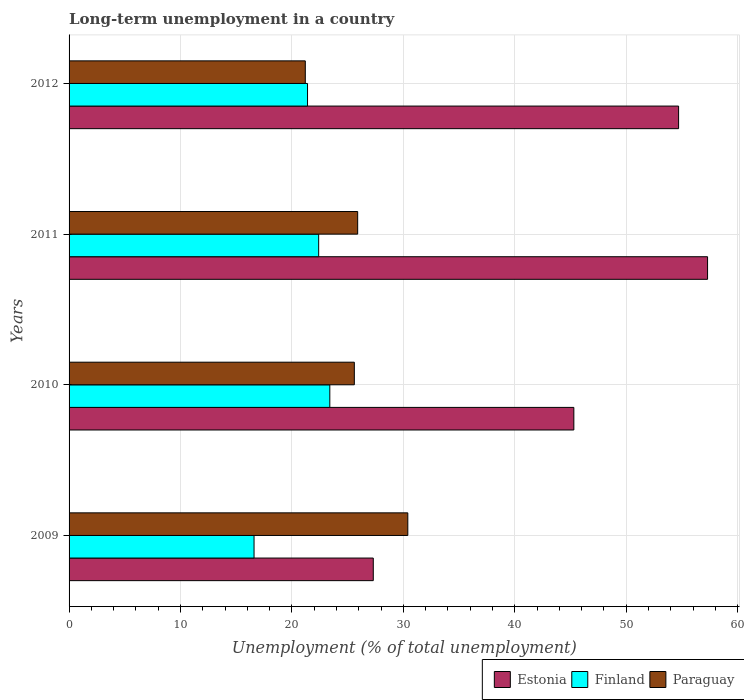How many different coloured bars are there?
Offer a very short reply. 3. How many groups of bars are there?
Your answer should be compact. 4. Are the number of bars on each tick of the Y-axis equal?
Keep it short and to the point. Yes. How many bars are there on the 4th tick from the top?
Provide a short and direct response. 3. What is the label of the 2nd group of bars from the top?
Provide a short and direct response. 2011. In how many cases, is the number of bars for a given year not equal to the number of legend labels?
Your response must be concise. 0. What is the percentage of long-term unemployed population in Paraguay in 2012?
Give a very brief answer. 21.2. Across all years, what is the maximum percentage of long-term unemployed population in Paraguay?
Ensure brevity in your answer.  30.4. Across all years, what is the minimum percentage of long-term unemployed population in Paraguay?
Provide a succinct answer. 21.2. What is the total percentage of long-term unemployed population in Finland in the graph?
Your answer should be compact. 83.8. What is the difference between the percentage of long-term unemployed population in Paraguay in 2009 and that in 2011?
Your answer should be very brief. 4.5. What is the difference between the percentage of long-term unemployed population in Estonia in 2010 and the percentage of long-term unemployed population in Paraguay in 2009?
Keep it short and to the point. 14.9. What is the average percentage of long-term unemployed population in Estonia per year?
Give a very brief answer. 46.15. In the year 2012, what is the difference between the percentage of long-term unemployed population in Finland and percentage of long-term unemployed population in Estonia?
Provide a succinct answer. -33.3. In how many years, is the percentage of long-term unemployed population in Paraguay greater than 38 %?
Give a very brief answer. 0. What is the ratio of the percentage of long-term unemployed population in Finland in 2011 to that in 2012?
Your response must be concise. 1.05. What is the difference between the highest and the lowest percentage of long-term unemployed population in Paraguay?
Your response must be concise. 9.2. What does the 1st bar from the bottom in 2012 represents?
Offer a very short reply. Estonia. Is it the case that in every year, the sum of the percentage of long-term unemployed population in Paraguay and percentage of long-term unemployed population in Estonia is greater than the percentage of long-term unemployed population in Finland?
Keep it short and to the point. Yes. Are all the bars in the graph horizontal?
Offer a very short reply. Yes. How many years are there in the graph?
Your answer should be compact. 4. What is the difference between two consecutive major ticks on the X-axis?
Offer a very short reply. 10. Are the values on the major ticks of X-axis written in scientific E-notation?
Offer a terse response. No. Does the graph contain any zero values?
Make the answer very short. No. How many legend labels are there?
Give a very brief answer. 3. How are the legend labels stacked?
Your answer should be compact. Horizontal. What is the title of the graph?
Offer a terse response. Long-term unemployment in a country. What is the label or title of the X-axis?
Provide a succinct answer. Unemployment (% of total unemployment). What is the label or title of the Y-axis?
Ensure brevity in your answer.  Years. What is the Unemployment (% of total unemployment) in Estonia in 2009?
Provide a short and direct response. 27.3. What is the Unemployment (% of total unemployment) of Finland in 2009?
Offer a very short reply. 16.6. What is the Unemployment (% of total unemployment) in Paraguay in 2009?
Your answer should be compact. 30.4. What is the Unemployment (% of total unemployment) of Estonia in 2010?
Your response must be concise. 45.3. What is the Unemployment (% of total unemployment) in Finland in 2010?
Make the answer very short. 23.4. What is the Unemployment (% of total unemployment) of Paraguay in 2010?
Your response must be concise. 25.6. What is the Unemployment (% of total unemployment) of Estonia in 2011?
Provide a short and direct response. 57.3. What is the Unemployment (% of total unemployment) in Finland in 2011?
Provide a short and direct response. 22.4. What is the Unemployment (% of total unemployment) in Paraguay in 2011?
Ensure brevity in your answer.  25.9. What is the Unemployment (% of total unemployment) in Estonia in 2012?
Offer a terse response. 54.7. What is the Unemployment (% of total unemployment) of Finland in 2012?
Give a very brief answer. 21.4. What is the Unemployment (% of total unemployment) of Paraguay in 2012?
Your answer should be compact. 21.2. Across all years, what is the maximum Unemployment (% of total unemployment) of Estonia?
Give a very brief answer. 57.3. Across all years, what is the maximum Unemployment (% of total unemployment) in Finland?
Give a very brief answer. 23.4. Across all years, what is the maximum Unemployment (% of total unemployment) in Paraguay?
Ensure brevity in your answer.  30.4. Across all years, what is the minimum Unemployment (% of total unemployment) of Estonia?
Ensure brevity in your answer.  27.3. Across all years, what is the minimum Unemployment (% of total unemployment) of Finland?
Your answer should be very brief. 16.6. Across all years, what is the minimum Unemployment (% of total unemployment) in Paraguay?
Make the answer very short. 21.2. What is the total Unemployment (% of total unemployment) of Estonia in the graph?
Provide a short and direct response. 184.6. What is the total Unemployment (% of total unemployment) in Finland in the graph?
Provide a succinct answer. 83.8. What is the total Unemployment (% of total unemployment) of Paraguay in the graph?
Your answer should be very brief. 103.1. What is the difference between the Unemployment (% of total unemployment) in Estonia in 2009 and that in 2010?
Provide a short and direct response. -18. What is the difference between the Unemployment (% of total unemployment) of Estonia in 2009 and that in 2011?
Keep it short and to the point. -30. What is the difference between the Unemployment (% of total unemployment) in Paraguay in 2009 and that in 2011?
Provide a succinct answer. 4.5. What is the difference between the Unemployment (% of total unemployment) in Estonia in 2009 and that in 2012?
Keep it short and to the point. -27.4. What is the difference between the Unemployment (% of total unemployment) of Finland in 2009 and that in 2012?
Give a very brief answer. -4.8. What is the difference between the Unemployment (% of total unemployment) of Paraguay in 2009 and that in 2012?
Give a very brief answer. 9.2. What is the difference between the Unemployment (% of total unemployment) of Estonia in 2010 and that in 2011?
Make the answer very short. -12. What is the difference between the Unemployment (% of total unemployment) in Finland in 2010 and that in 2011?
Your response must be concise. 1. What is the difference between the Unemployment (% of total unemployment) of Finland in 2010 and that in 2012?
Offer a very short reply. 2. What is the difference between the Unemployment (% of total unemployment) of Paraguay in 2010 and that in 2012?
Give a very brief answer. 4.4. What is the difference between the Unemployment (% of total unemployment) in Estonia in 2011 and that in 2012?
Your response must be concise. 2.6. What is the difference between the Unemployment (% of total unemployment) in Finland in 2011 and that in 2012?
Provide a short and direct response. 1. What is the difference between the Unemployment (% of total unemployment) of Paraguay in 2011 and that in 2012?
Your answer should be very brief. 4.7. What is the difference between the Unemployment (% of total unemployment) of Estonia in 2009 and the Unemployment (% of total unemployment) of Paraguay in 2010?
Provide a short and direct response. 1.7. What is the difference between the Unemployment (% of total unemployment) in Finland in 2009 and the Unemployment (% of total unemployment) in Paraguay in 2010?
Ensure brevity in your answer.  -9. What is the difference between the Unemployment (% of total unemployment) of Estonia in 2009 and the Unemployment (% of total unemployment) of Finland in 2011?
Give a very brief answer. 4.9. What is the difference between the Unemployment (% of total unemployment) in Estonia in 2009 and the Unemployment (% of total unemployment) in Paraguay in 2011?
Make the answer very short. 1.4. What is the difference between the Unemployment (% of total unemployment) of Finland in 2009 and the Unemployment (% of total unemployment) of Paraguay in 2011?
Keep it short and to the point. -9.3. What is the difference between the Unemployment (% of total unemployment) of Estonia in 2009 and the Unemployment (% of total unemployment) of Paraguay in 2012?
Offer a terse response. 6.1. What is the difference between the Unemployment (% of total unemployment) in Finland in 2009 and the Unemployment (% of total unemployment) in Paraguay in 2012?
Your answer should be very brief. -4.6. What is the difference between the Unemployment (% of total unemployment) of Estonia in 2010 and the Unemployment (% of total unemployment) of Finland in 2011?
Offer a terse response. 22.9. What is the difference between the Unemployment (% of total unemployment) in Finland in 2010 and the Unemployment (% of total unemployment) in Paraguay in 2011?
Offer a terse response. -2.5. What is the difference between the Unemployment (% of total unemployment) of Estonia in 2010 and the Unemployment (% of total unemployment) of Finland in 2012?
Keep it short and to the point. 23.9. What is the difference between the Unemployment (% of total unemployment) of Estonia in 2010 and the Unemployment (% of total unemployment) of Paraguay in 2012?
Your response must be concise. 24.1. What is the difference between the Unemployment (% of total unemployment) of Finland in 2010 and the Unemployment (% of total unemployment) of Paraguay in 2012?
Your response must be concise. 2.2. What is the difference between the Unemployment (% of total unemployment) of Estonia in 2011 and the Unemployment (% of total unemployment) of Finland in 2012?
Offer a terse response. 35.9. What is the difference between the Unemployment (% of total unemployment) in Estonia in 2011 and the Unemployment (% of total unemployment) in Paraguay in 2012?
Your response must be concise. 36.1. What is the difference between the Unemployment (% of total unemployment) of Finland in 2011 and the Unemployment (% of total unemployment) of Paraguay in 2012?
Provide a succinct answer. 1.2. What is the average Unemployment (% of total unemployment) of Estonia per year?
Provide a succinct answer. 46.15. What is the average Unemployment (% of total unemployment) of Finland per year?
Make the answer very short. 20.95. What is the average Unemployment (% of total unemployment) in Paraguay per year?
Give a very brief answer. 25.77. In the year 2009, what is the difference between the Unemployment (% of total unemployment) in Estonia and Unemployment (% of total unemployment) in Finland?
Your answer should be compact. 10.7. In the year 2009, what is the difference between the Unemployment (% of total unemployment) of Estonia and Unemployment (% of total unemployment) of Paraguay?
Provide a succinct answer. -3.1. In the year 2009, what is the difference between the Unemployment (% of total unemployment) in Finland and Unemployment (% of total unemployment) in Paraguay?
Offer a very short reply. -13.8. In the year 2010, what is the difference between the Unemployment (% of total unemployment) in Estonia and Unemployment (% of total unemployment) in Finland?
Offer a very short reply. 21.9. In the year 2010, what is the difference between the Unemployment (% of total unemployment) of Estonia and Unemployment (% of total unemployment) of Paraguay?
Keep it short and to the point. 19.7. In the year 2011, what is the difference between the Unemployment (% of total unemployment) in Estonia and Unemployment (% of total unemployment) in Finland?
Keep it short and to the point. 34.9. In the year 2011, what is the difference between the Unemployment (% of total unemployment) of Estonia and Unemployment (% of total unemployment) of Paraguay?
Keep it short and to the point. 31.4. In the year 2011, what is the difference between the Unemployment (% of total unemployment) in Finland and Unemployment (% of total unemployment) in Paraguay?
Your response must be concise. -3.5. In the year 2012, what is the difference between the Unemployment (% of total unemployment) in Estonia and Unemployment (% of total unemployment) in Finland?
Ensure brevity in your answer.  33.3. In the year 2012, what is the difference between the Unemployment (% of total unemployment) in Estonia and Unemployment (% of total unemployment) in Paraguay?
Give a very brief answer. 33.5. What is the ratio of the Unemployment (% of total unemployment) of Estonia in 2009 to that in 2010?
Provide a succinct answer. 0.6. What is the ratio of the Unemployment (% of total unemployment) in Finland in 2009 to that in 2010?
Make the answer very short. 0.71. What is the ratio of the Unemployment (% of total unemployment) of Paraguay in 2009 to that in 2010?
Your answer should be compact. 1.19. What is the ratio of the Unemployment (% of total unemployment) in Estonia in 2009 to that in 2011?
Give a very brief answer. 0.48. What is the ratio of the Unemployment (% of total unemployment) of Finland in 2009 to that in 2011?
Your answer should be very brief. 0.74. What is the ratio of the Unemployment (% of total unemployment) in Paraguay in 2009 to that in 2011?
Make the answer very short. 1.17. What is the ratio of the Unemployment (% of total unemployment) of Estonia in 2009 to that in 2012?
Provide a short and direct response. 0.5. What is the ratio of the Unemployment (% of total unemployment) in Finland in 2009 to that in 2012?
Offer a very short reply. 0.78. What is the ratio of the Unemployment (% of total unemployment) of Paraguay in 2009 to that in 2012?
Give a very brief answer. 1.43. What is the ratio of the Unemployment (% of total unemployment) in Estonia in 2010 to that in 2011?
Your answer should be very brief. 0.79. What is the ratio of the Unemployment (% of total unemployment) of Finland in 2010 to that in 2011?
Provide a succinct answer. 1.04. What is the ratio of the Unemployment (% of total unemployment) in Paraguay in 2010 to that in 2011?
Ensure brevity in your answer.  0.99. What is the ratio of the Unemployment (% of total unemployment) of Estonia in 2010 to that in 2012?
Make the answer very short. 0.83. What is the ratio of the Unemployment (% of total unemployment) of Finland in 2010 to that in 2012?
Your response must be concise. 1.09. What is the ratio of the Unemployment (% of total unemployment) in Paraguay in 2010 to that in 2012?
Keep it short and to the point. 1.21. What is the ratio of the Unemployment (% of total unemployment) of Estonia in 2011 to that in 2012?
Your response must be concise. 1.05. What is the ratio of the Unemployment (% of total unemployment) in Finland in 2011 to that in 2012?
Keep it short and to the point. 1.05. What is the ratio of the Unemployment (% of total unemployment) in Paraguay in 2011 to that in 2012?
Give a very brief answer. 1.22. What is the difference between the highest and the lowest Unemployment (% of total unemployment) of Finland?
Offer a terse response. 6.8. What is the difference between the highest and the lowest Unemployment (% of total unemployment) in Paraguay?
Your answer should be very brief. 9.2. 